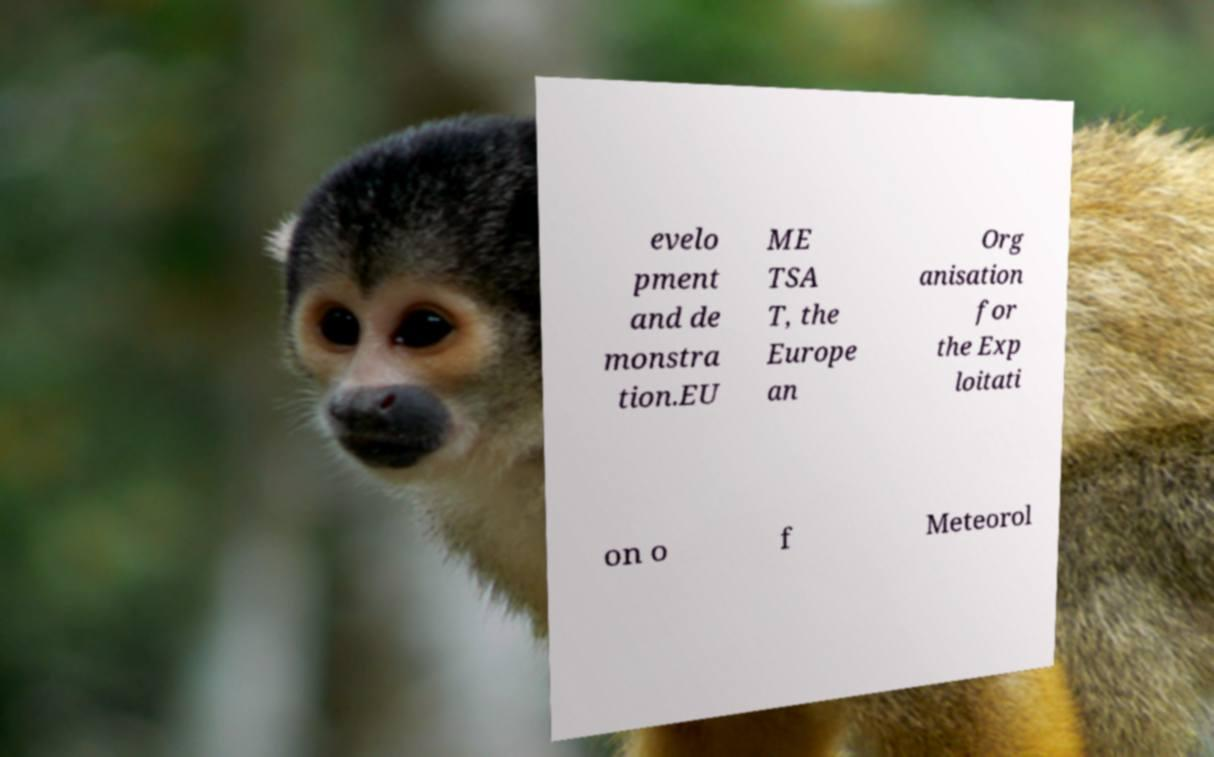Please identify and transcribe the text found in this image. evelo pment and de monstra tion.EU ME TSA T, the Europe an Org anisation for the Exp loitati on o f Meteorol 